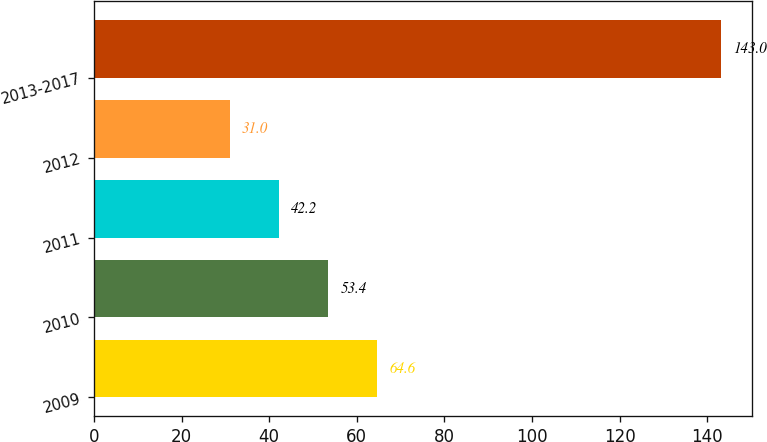Convert chart to OTSL. <chart><loc_0><loc_0><loc_500><loc_500><bar_chart><fcel>2009<fcel>2010<fcel>2011<fcel>2012<fcel>2013-2017<nl><fcel>64.6<fcel>53.4<fcel>42.2<fcel>31<fcel>143<nl></chart> 